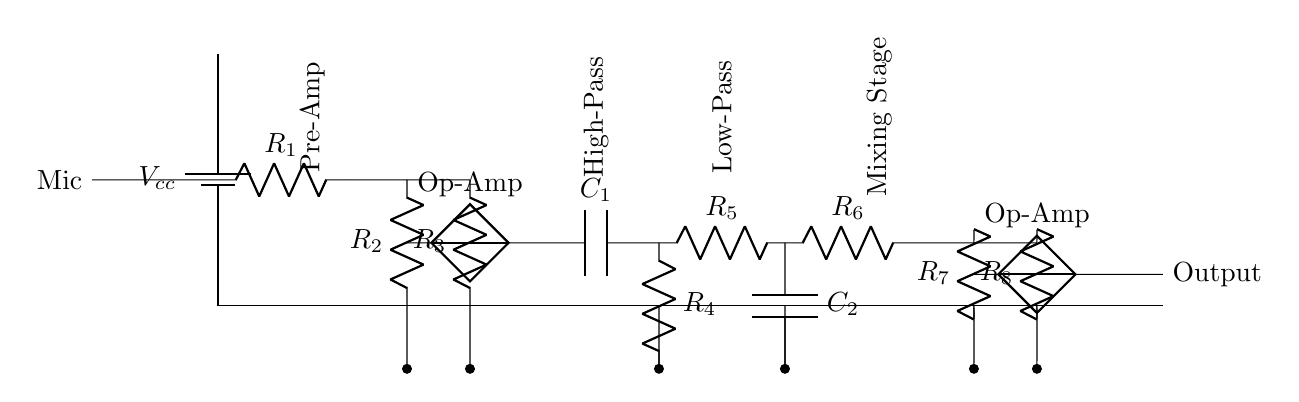What is the power supply component in this circuit? The power supply component is a battery, indicated as Vcc. It provides the necessary voltage for the circuit's operation.
Answer: Battery What type of filter is employed after the pre-amplifier? The circuit contains a high-pass filter, which is formed by the capacitor C1 and resistor R4, allowing frequencies above a certain cutoff to pass through while attenuating lower frequencies.
Answer: High-pass How many resistors are present in the mixing stage? The mixing stage consists of three resistors, labeled R6, R7, and R8, which function together to mix the signals before output.
Answer: Three What component type is used for audio input? The audio input is handled by a microphone, which captures sound waves and converts them into electrical signals for processing in the circuit.
Answer: Microphone What is the configuration of the operational amplifier used in this circuit? The operational amplifier (Op-Amp) is connected in a non-inverting configuration, allowing it to amplify the input signal effectively without inverting its phase.
Answer: Non-inverting What is the effect of the low-pass filter in this circuit? The low-pass filter, composed of resistor R5 and capacitor C2, allows low-frequency components of the audio signal to pass while attenuating high-frequency noise, resulting in a cleaner sound effect.
Answer: Attenuates high frequencies 